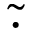<formula> <loc_0><loc_0><loc_500><loc_500>\tilde { \cdot }</formula> 